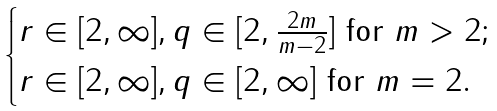Convert formula to latex. <formula><loc_0><loc_0><loc_500><loc_500>\begin{cases} r \in [ 2 , \infty ] , q \in [ 2 , \frac { 2 m } { m - 2 } ] \text { for } m > 2 ; \\ r \in [ 2 , \infty ] , q \in [ 2 , \infty ] \text { for } m = 2 . \\ \end{cases}</formula> 